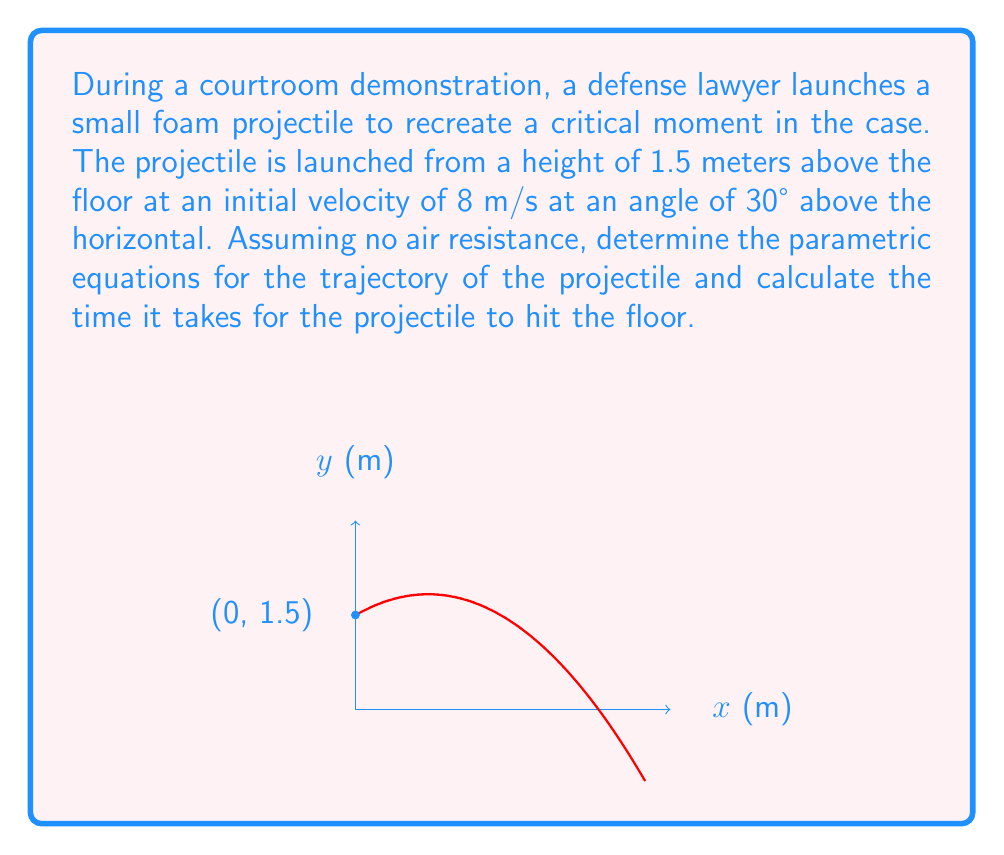Help me with this question. Let's approach this step-by-step:

1) First, we need to identify the components of the initial velocity:
   $v_x = v \cos \theta = 8 \cos 30° = 8 \cdot \frac{\sqrt{3}}{2} = 4\sqrt{3}$ m/s
   $v_y = v \sin \theta = 8 \sin 30° = 8 \cdot \frac{1}{2} = 4$ m/s

2) Now, we can write the parametric equations for the position of the projectile:
   $x(t) = v_x t = 4\sqrt{3}t$
   $y(t) = -\frac{1}{2}gt^2 + v_y t + y_0 = -4.9t^2 + 4t + 1.5$

   Where $g = 9.8$ m/s² is the acceleration due to gravity, and $y_0 = 1.5$ m is the initial height.

3) To find the time when the projectile hits the floor, we need to solve $y(t) = 0$:
   $0 = -4.9t^2 + 4t + 1.5$

4) This is a quadratic equation. We can solve it using the quadratic formula:
   $t = \frac{-b \pm \sqrt{b^2 - 4ac}}{2a}$

   Where $a = -4.9$, $b = 4$, and $c = 1.5$

5) Plugging in these values:
   $t = \frac{-4 \pm \sqrt{16 + 29.4}}{-9.8} = \frac{-4 \pm \sqrt{45.4}}{-9.8}$

6) This gives us two solutions:
   $t_1 \approx -0.31$ s (which we discard as time can't be negative)
   $t_2 \approx 1.13$ s

Therefore, the projectile will hit the floor after approximately 1.13 seconds.
Answer: Parametric equations: $x(t) = 4\sqrt{3}t$, $y(t) = -4.9t^2 + 4t + 1.5$
Time to hit floor: $t \approx 1.13$ s 